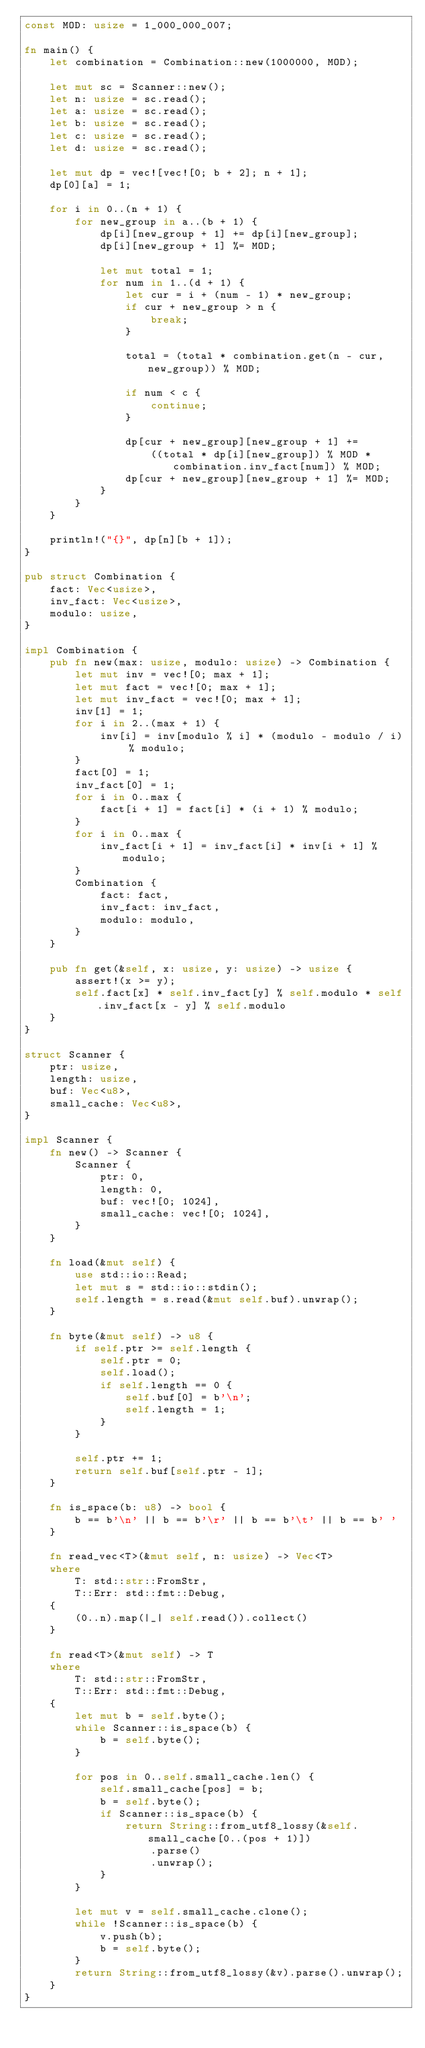Convert code to text. <code><loc_0><loc_0><loc_500><loc_500><_Rust_>const MOD: usize = 1_000_000_007;

fn main() {
    let combination = Combination::new(1000000, MOD);

    let mut sc = Scanner::new();
    let n: usize = sc.read();
    let a: usize = sc.read();
    let b: usize = sc.read();
    let c: usize = sc.read();
    let d: usize = sc.read();

    let mut dp = vec![vec![0; b + 2]; n + 1];
    dp[0][a] = 1;

    for i in 0..(n + 1) {
        for new_group in a..(b + 1) {
            dp[i][new_group + 1] += dp[i][new_group];
            dp[i][new_group + 1] %= MOD;

            let mut total = 1;
            for num in 1..(d + 1) {
                let cur = i + (num - 1) * new_group;
                if cur + new_group > n {
                    break;
                }

                total = (total * combination.get(n - cur, new_group)) % MOD;

                if num < c {
                    continue;
                }

                dp[cur + new_group][new_group + 1] +=
                    ((total * dp[i][new_group]) % MOD * combination.inv_fact[num]) % MOD;
                dp[cur + new_group][new_group + 1] %= MOD;
            }
        }
    }

    println!("{}", dp[n][b + 1]);
}

pub struct Combination {
    fact: Vec<usize>,
    inv_fact: Vec<usize>,
    modulo: usize,
}

impl Combination {
    pub fn new(max: usize, modulo: usize) -> Combination {
        let mut inv = vec![0; max + 1];
        let mut fact = vec![0; max + 1];
        let mut inv_fact = vec![0; max + 1];
        inv[1] = 1;
        for i in 2..(max + 1) {
            inv[i] = inv[modulo % i] * (modulo - modulo / i) % modulo;
        }
        fact[0] = 1;
        inv_fact[0] = 1;
        for i in 0..max {
            fact[i + 1] = fact[i] * (i + 1) % modulo;
        }
        for i in 0..max {
            inv_fact[i + 1] = inv_fact[i] * inv[i + 1] % modulo;
        }
        Combination {
            fact: fact,
            inv_fact: inv_fact,
            modulo: modulo,
        }
    }

    pub fn get(&self, x: usize, y: usize) -> usize {
        assert!(x >= y);
        self.fact[x] * self.inv_fact[y] % self.modulo * self.inv_fact[x - y] % self.modulo
    }
}

struct Scanner {
    ptr: usize,
    length: usize,
    buf: Vec<u8>,
    small_cache: Vec<u8>,
}

impl Scanner {
    fn new() -> Scanner {
        Scanner {
            ptr: 0,
            length: 0,
            buf: vec![0; 1024],
            small_cache: vec![0; 1024],
        }
    }

    fn load(&mut self) {
        use std::io::Read;
        let mut s = std::io::stdin();
        self.length = s.read(&mut self.buf).unwrap();
    }

    fn byte(&mut self) -> u8 {
        if self.ptr >= self.length {
            self.ptr = 0;
            self.load();
            if self.length == 0 {
                self.buf[0] = b'\n';
                self.length = 1;
            }
        }

        self.ptr += 1;
        return self.buf[self.ptr - 1];
    }

    fn is_space(b: u8) -> bool {
        b == b'\n' || b == b'\r' || b == b'\t' || b == b' '
    }

    fn read_vec<T>(&mut self, n: usize) -> Vec<T>
    where
        T: std::str::FromStr,
        T::Err: std::fmt::Debug,
    {
        (0..n).map(|_| self.read()).collect()
    }

    fn read<T>(&mut self) -> T
    where
        T: std::str::FromStr,
        T::Err: std::fmt::Debug,
    {
        let mut b = self.byte();
        while Scanner::is_space(b) {
            b = self.byte();
        }

        for pos in 0..self.small_cache.len() {
            self.small_cache[pos] = b;
            b = self.byte();
            if Scanner::is_space(b) {
                return String::from_utf8_lossy(&self.small_cache[0..(pos + 1)])
                    .parse()
                    .unwrap();
            }
        }

        let mut v = self.small_cache.clone();
        while !Scanner::is_space(b) {
            v.push(b);
            b = self.byte();
        }
        return String::from_utf8_lossy(&v).parse().unwrap();
    }
}
</code> 